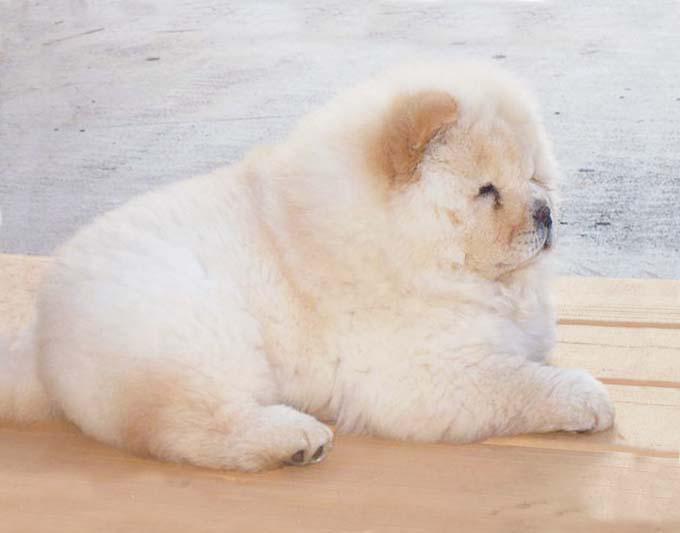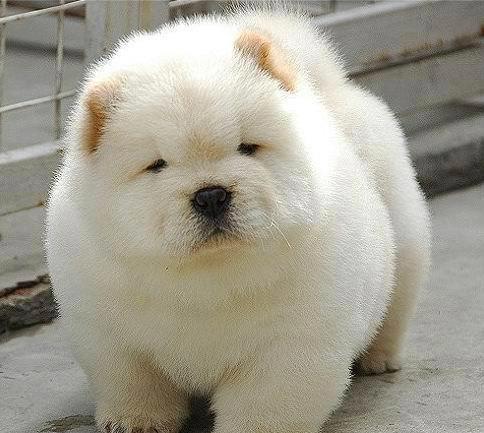The first image is the image on the left, the second image is the image on the right. Considering the images on both sides, is "There are more chow dogs in the image on the right." valid? Answer yes or no. No. 